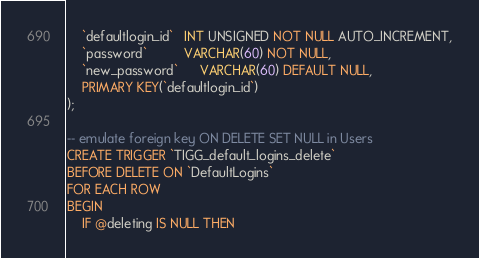<code> <loc_0><loc_0><loc_500><loc_500><_SQL_>    `defaultlogin_id`   INT UNSIGNED NOT NULL AUTO_INCREMENT,
    `password`          VARCHAR(60) NOT NULL,
    `new_password`      VARCHAR(60) DEFAULT NULL,
    PRIMARY KEY(`defaultlogin_id`)
);

-- emulate foreign key ON DELETE SET NULL in Users
CREATE TRIGGER `TIGG_default_logins_delete` 
BEFORE DELETE ON `DefaultLogins`
FOR EACH ROW
BEGIN
    IF @deleting IS NULL THEN</code> 